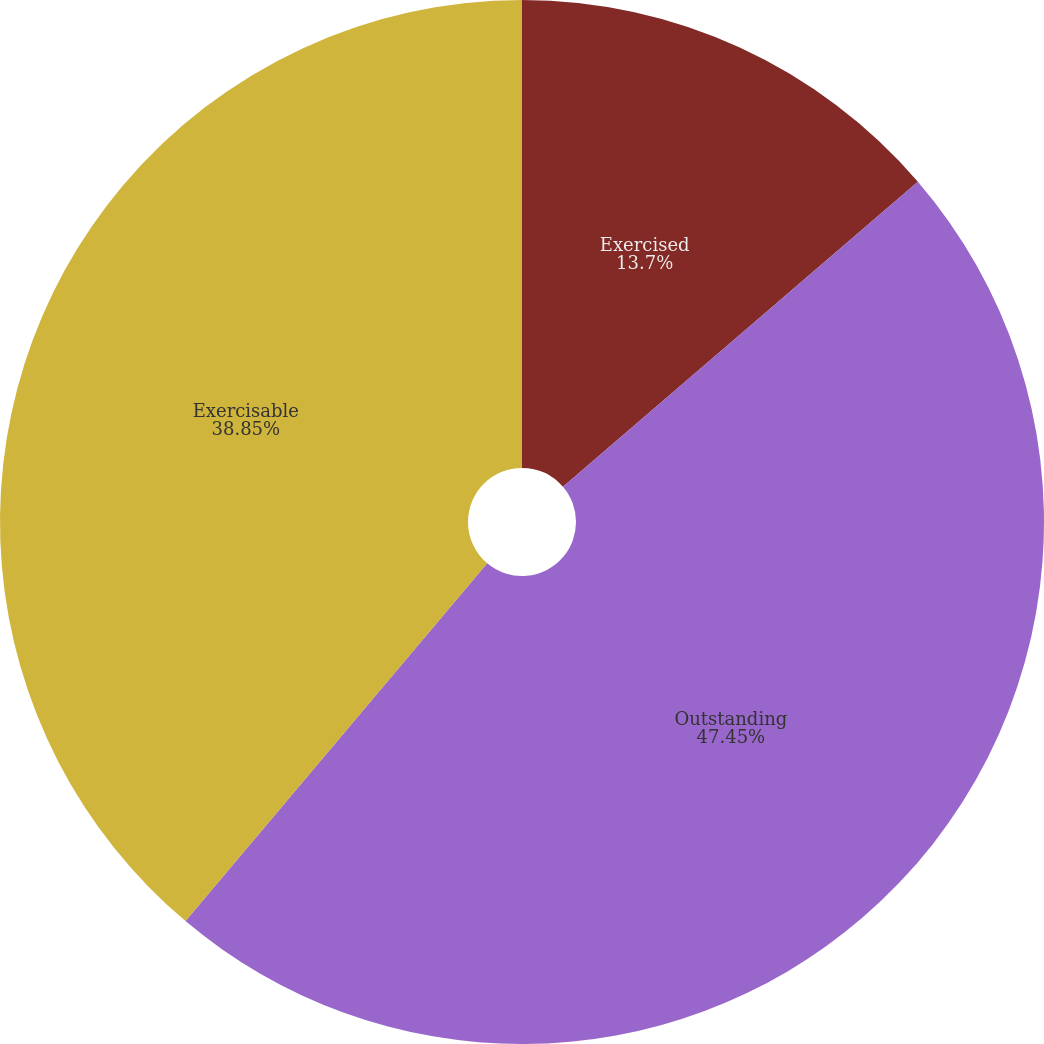Convert chart. <chart><loc_0><loc_0><loc_500><loc_500><pie_chart><fcel>Exercised<fcel>Outstanding<fcel>Exercisable<nl><fcel>13.7%<fcel>47.45%<fcel>38.85%<nl></chart> 